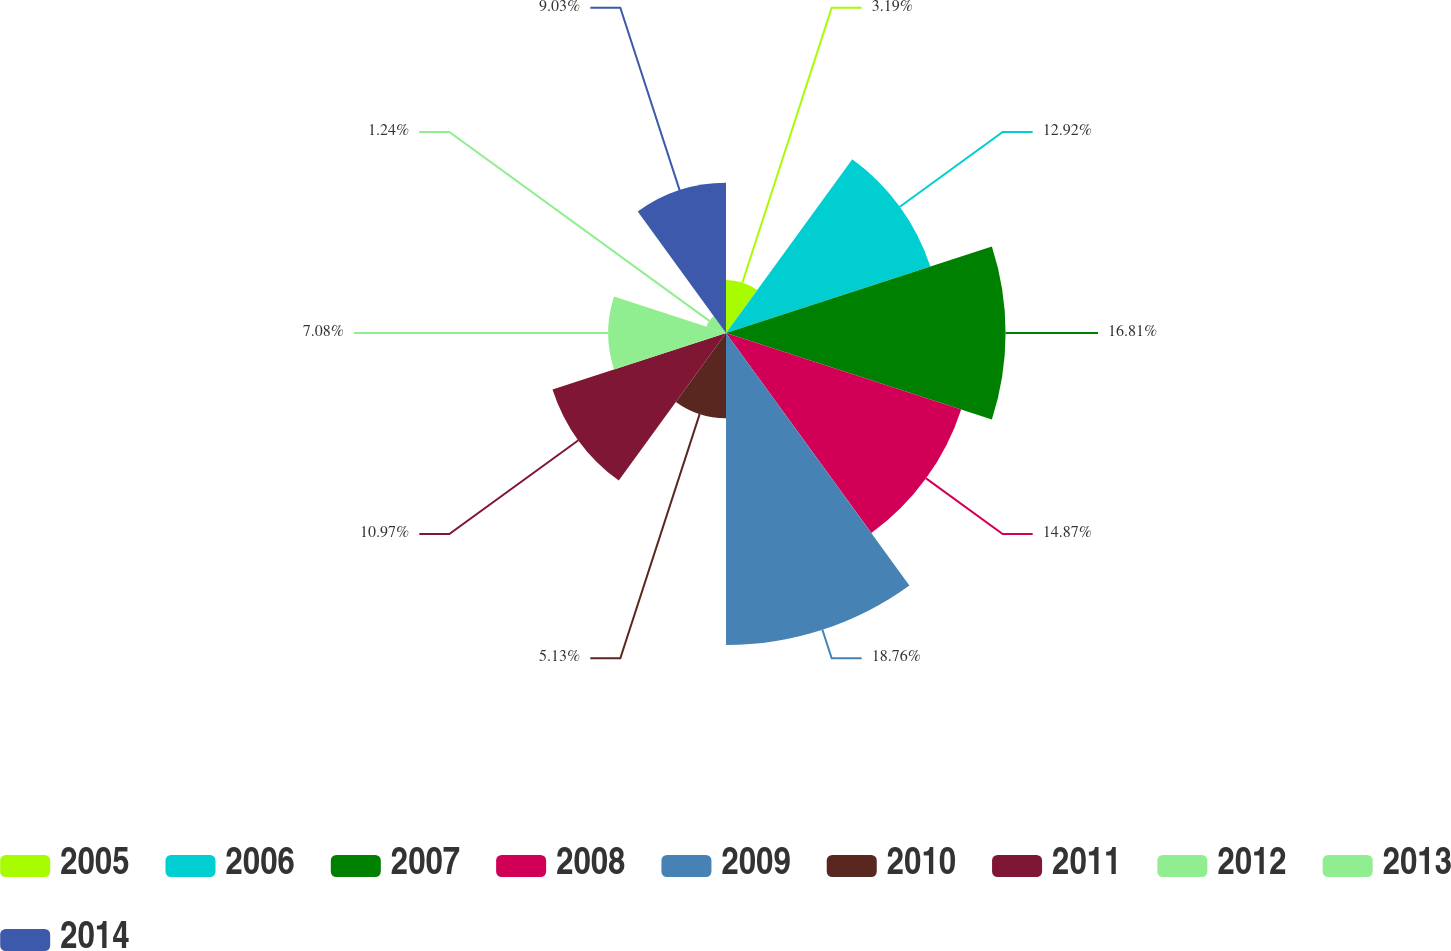Convert chart. <chart><loc_0><loc_0><loc_500><loc_500><pie_chart><fcel>2005<fcel>2006<fcel>2007<fcel>2008<fcel>2009<fcel>2010<fcel>2011<fcel>2012<fcel>2013<fcel>2014<nl><fcel>3.19%<fcel>12.92%<fcel>16.81%<fcel>14.87%<fcel>18.76%<fcel>5.13%<fcel>10.97%<fcel>7.08%<fcel>1.24%<fcel>9.03%<nl></chart> 